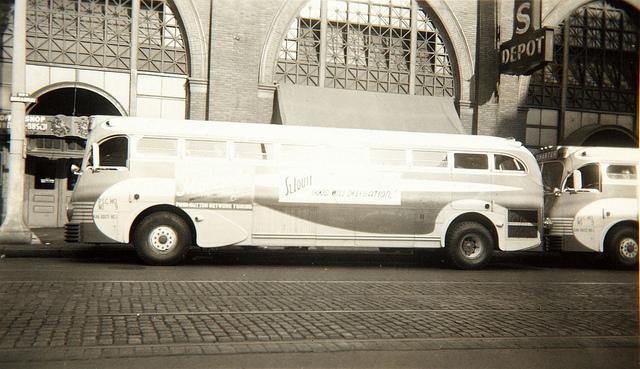Is this vehicle able to hold many people?
Concise answer only. Yes. What is the facade of the building behind the vehicle made up of?
Concise answer only. Brick. How many wheels are there?
Short answer required. 3. Is this picture in color?
Be succinct. No. Where is the bus going?
Quick response, please. Left. 